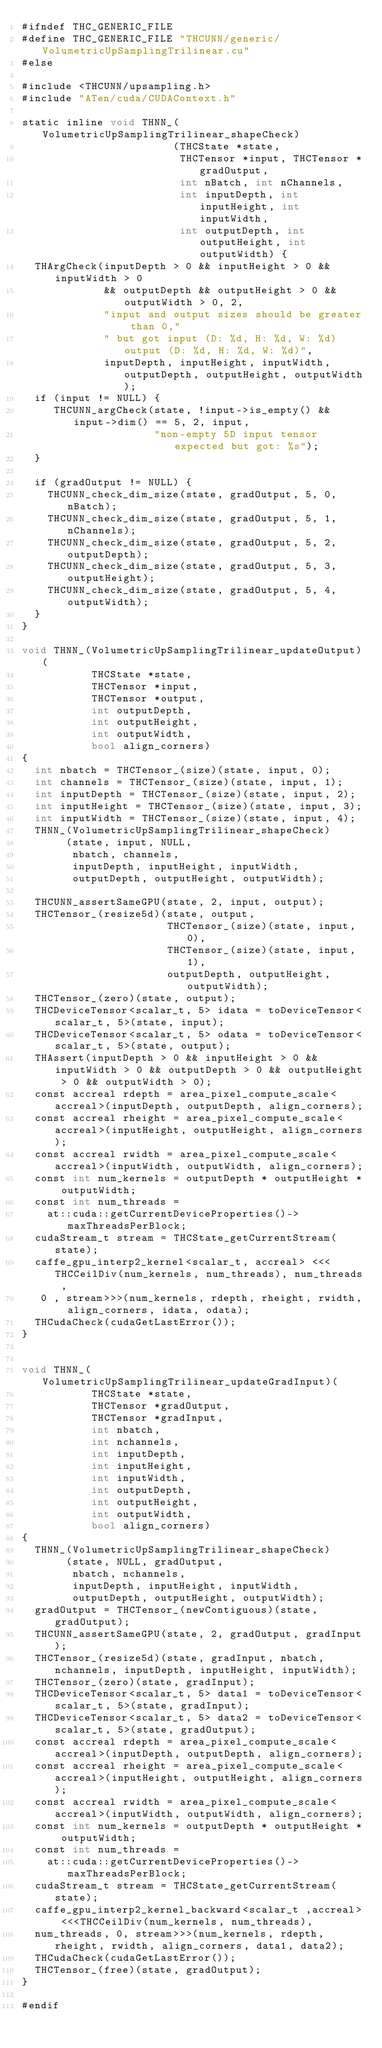Convert code to text. <code><loc_0><loc_0><loc_500><loc_500><_Cuda_>#ifndef THC_GENERIC_FILE
#define THC_GENERIC_FILE "THCUNN/generic/VolumetricUpSamplingTrilinear.cu"
#else

#include <THCUNN/upsampling.h>
#include "ATen/cuda/CUDAContext.h"

static inline void THNN_(VolumetricUpSamplingTrilinear_shapeCheck)
                        (THCState *state,
                         THCTensor *input, THCTensor *gradOutput,
                         int nBatch, int nChannels,
                         int inputDepth, int inputHeight, int inputWidth,
                         int outputDepth, int outputHeight, int outputWidth) {
  THArgCheck(inputDepth > 0 && inputHeight > 0 && inputWidth > 0
             && outputDepth && outputHeight > 0 && outputWidth > 0, 2,
             "input and output sizes should be greater than 0,"
             " but got input (D: %d, H: %d, W: %d) output (D: %d, H: %d, W: %d)",
             inputDepth, inputHeight, inputWidth, outputDepth, outputHeight, outputWidth);
  if (input != NULL) {
     THCUNN_argCheck(state, !input->is_empty() && input->dim() == 5, 2, input,
                     "non-empty 5D input tensor expected but got: %s");
  }

  if (gradOutput != NULL) {
    THCUNN_check_dim_size(state, gradOutput, 5, 0, nBatch);
    THCUNN_check_dim_size(state, gradOutput, 5, 1, nChannels);
    THCUNN_check_dim_size(state, gradOutput, 5, 2, outputDepth);
    THCUNN_check_dim_size(state, gradOutput, 5, 3, outputHeight);
    THCUNN_check_dim_size(state, gradOutput, 5, 4, outputWidth);
  }
}

void THNN_(VolumetricUpSamplingTrilinear_updateOutput)(
           THCState *state,
           THCTensor *input,
           THCTensor *output,
           int outputDepth,
           int outputHeight,
           int outputWidth,
           bool align_corners)
{
  int nbatch = THCTensor_(size)(state, input, 0);
  int channels = THCTensor_(size)(state, input, 1);
  int inputDepth = THCTensor_(size)(state, input, 2);
  int inputHeight = THCTensor_(size)(state, input, 3);
  int inputWidth = THCTensor_(size)(state, input, 4);
  THNN_(VolumetricUpSamplingTrilinear_shapeCheck)
       (state, input, NULL,
        nbatch, channels,
        inputDepth, inputHeight, inputWidth,
        outputDepth, outputHeight, outputWidth);

  THCUNN_assertSameGPU(state, 2, input, output);
  THCTensor_(resize5d)(state, output,
                       THCTensor_(size)(state, input, 0),
                       THCTensor_(size)(state, input, 1),
                       outputDepth, outputHeight, outputWidth);
  THCTensor_(zero)(state, output);
  THCDeviceTensor<scalar_t, 5> idata = toDeviceTensor<scalar_t, 5>(state, input);
  THCDeviceTensor<scalar_t, 5> odata = toDeviceTensor<scalar_t, 5>(state, output);
  THAssert(inputDepth > 0 && inputHeight > 0 && inputWidth > 0 && outputDepth > 0 && outputHeight > 0 && outputWidth > 0);
  const accreal rdepth = area_pixel_compute_scale<accreal>(inputDepth, outputDepth, align_corners);
  const accreal rheight = area_pixel_compute_scale<accreal>(inputHeight, outputHeight, align_corners);
  const accreal rwidth = area_pixel_compute_scale<accreal>(inputWidth, outputWidth, align_corners);
  const int num_kernels = outputDepth * outputHeight * outputWidth;
  const int num_threads =
    at::cuda::getCurrentDeviceProperties()->maxThreadsPerBlock;
  cudaStream_t stream = THCState_getCurrentStream(state);
  caffe_gpu_interp2_kernel<scalar_t, accreal> <<<THCCeilDiv(num_kernels, num_threads), num_threads ,
   0 , stream>>>(num_kernels, rdepth, rheight, rwidth, align_corners, idata, odata);
  THCudaCheck(cudaGetLastError());
}


void THNN_(VolumetricUpSamplingTrilinear_updateGradInput)(
           THCState *state,
           THCTensor *gradOutput,
           THCTensor *gradInput,
           int nbatch,
           int nchannels,
           int inputDepth,
           int inputHeight,
           int inputWidth,
           int outputDepth,
           int outputHeight,
           int outputWidth,
           bool align_corners)
{
  THNN_(VolumetricUpSamplingTrilinear_shapeCheck)
       (state, NULL, gradOutput,
        nbatch, nchannels,
        inputDepth, inputHeight, inputWidth,
        outputDepth, outputHeight, outputWidth);
  gradOutput = THCTensor_(newContiguous)(state, gradOutput);
  THCUNN_assertSameGPU(state, 2, gradOutput, gradInput);
  THCTensor_(resize5d)(state, gradInput, nbatch, nchannels, inputDepth, inputHeight, inputWidth);
  THCTensor_(zero)(state, gradInput);
  THCDeviceTensor<scalar_t, 5> data1 = toDeviceTensor<scalar_t, 5>(state, gradInput);
  THCDeviceTensor<scalar_t, 5> data2 = toDeviceTensor<scalar_t, 5>(state, gradOutput);
  const accreal rdepth = area_pixel_compute_scale<accreal>(inputDepth, outputDepth, align_corners);
  const accreal rheight = area_pixel_compute_scale<accreal>(inputHeight, outputHeight, align_corners);
  const accreal rwidth = area_pixel_compute_scale<accreal>(inputWidth, outputWidth, align_corners);
  const int num_kernels = outputDepth * outputHeight * outputWidth;
  const int num_threads =
    at::cuda::getCurrentDeviceProperties()->maxThreadsPerBlock;
  cudaStream_t stream = THCState_getCurrentStream(state);
  caffe_gpu_interp2_kernel_backward<scalar_t ,accreal> <<<THCCeilDiv(num_kernels, num_threads),
  num_threads, 0, stream>>>(num_kernels, rdepth, rheight, rwidth, align_corners, data1, data2);
  THCudaCheck(cudaGetLastError());
  THCTensor_(free)(state, gradOutput);
}

#endif
</code> 